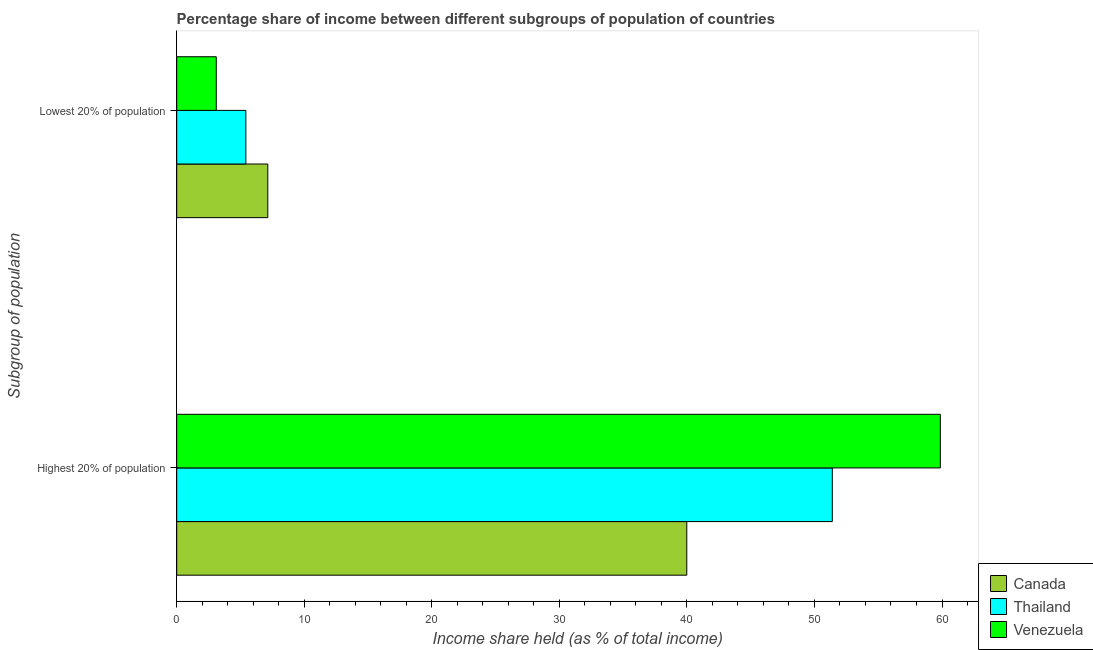How many different coloured bars are there?
Your answer should be very brief. 3. How many groups of bars are there?
Your answer should be very brief. 2. Are the number of bars per tick equal to the number of legend labels?
Your answer should be compact. Yes. How many bars are there on the 2nd tick from the top?
Offer a terse response. 3. How many bars are there on the 1st tick from the bottom?
Give a very brief answer. 3. What is the label of the 2nd group of bars from the top?
Your answer should be very brief. Highest 20% of population. What is the income share held by highest 20% of the population in Canada?
Your answer should be compact. 39.99. Across all countries, what is the maximum income share held by lowest 20% of the population?
Offer a terse response. 7.14. What is the total income share held by highest 20% of the population in the graph?
Your answer should be very brief. 151.26. What is the difference between the income share held by highest 20% of the population in Thailand and that in Canada?
Ensure brevity in your answer.  11.41. What is the difference between the income share held by highest 20% of the population in Canada and the income share held by lowest 20% of the population in Venezuela?
Make the answer very short. 36.89. What is the average income share held by highest 20% of the population per country?
Offer a terse response. 50.42. What is the difference between the income share held by lowest 20% of the population and income share held by highest 20% of the population in Thailand?
Provide a succinct answer. -45.98. What is the ratio of the income share held by lowest 20% of the population in Thailand to that in Venezuela?
Make the answer very short. 1.75. Is the income share held by lowest 20% of the population in Canada less than that in Venezuela?
Your response must be concise. No. What does the 2nd bar from the top in Highest 20% of population represents?
Give a very brief answer. Thailand. What does the 2nd bar from the bottom in Highest 20% of population represents?
Your answer should be compact. Thailand. How many bars are there?
Offer a terse response. 6. Are all the bars in the graph horizontal?
Your response must be concise. Yes. How many countries are there in the graph?
Ensure brevity in your answer.  3. Where does the legend appear in the graph?
Make the answer very short. Bottom right. How many legend labels are there?
Your answer should be very brief. 3. What is the title of the graph?
Your answer should be compact. Percentage share of income between different subgroups of population of countries. Does "Kuwait" appear as one of the legend labels in the graph?
Provide a succinct answer. No. What is the label or title of the X-axis?
Offer a terse response. Income share held (as % of total income). What is the label or title of the Y-axis?
Offer a very short reply. Subgroup of population. What is the Income share held (as % of total income) of Canada in Highest 20% of population?
Ensure brevity in your answer.  39.99. What is the Income share held (as % of total income) in Thailand in Highest 20% of population?
Your answer should be very brief. 51.4. What is the Income share held (as % of total income) in Venezuela in Highest 20% of population?
Your answer should be very brief. 59.87. What is the Income share held (as % of total income) in Canada in Lowest 20% of population?
Ensure brevity in your answer.  7.14. What is the Income share held (as % of total income) in Thailand in Lowest 20% of population?
Your answer should be very brief. 5.42. Across all Subgroup of population, what is the maximum Income share held (as % of total income) of Canada?
Provide a succinct answer. 39.99. Across all Subgroup of population, what is the maximum Income share held (as % of total income) of Thailand?
Make the answer very short. 51.4. Across all Subgroup of population, what is the maximum Income share held (as % of total income) in Venezuela?
Provide a succinct answer. 59.87. Across all Subgroup of population, what is the minimum Income share held (as % of total income) in Canada?
Your answer should be compact. 7.14. Across all Subgroup of population, what is the minimum Income share held (as % of total income) in Thailand?
Provide a short and direct response. 5.42. Across all Subgroup of population, what is the minimum Income share held (as % of total income) of Venezuela?
Your answer should be very brief. 3.1. What is the total Income share held (as % of total income) in Canada in the graph?
Provide a short and direct response. 47.13. What is the total Income share held (as % of total income) of Thailand in the graph?
Keep it short and to the point. 56.82. What is the total Income share held (as % of total income) of Venezuela in the graph?
Keep it short and to the point. 62.97. What is the difference between the Income share held (as % of total income) in Canada in Highest 20% of population and that in Lowest 20% of population?
Your answer should be very brief. 32.85. What is the difference between the Income share held (as % of total income) of Thailand in Highest 20% of population and that in Lowest 20% of population?
Your answer should be compact. 45.98. What is the difference between the Income share held (as % of total income) in Venezuela in Highest 20% of population and that in Lowest 20% of population?
Ensure brevity in your answer.  56.77. What is the difference between the Income share held (as % of total income) in Canada in Highest 20% of population and the Income share held (as % of total income) in Thailand in Lowest 20% of population?
Give a very brief answer. 34.57. What is the difference between the Income share held (as % of total income) of Canada in Highest 20% of population and the Income share held (as % of total income) of Venezuela in Lowest 20% of population?
Give a very brief answer. 36.89. What is the difference between the Income share held (as % of total income) in Thailand in Highest 20% of population and the Income share held (as % of total income) in Venezuela in Lowest 20% of population?
Provide a short and direct response. 48.3. What is the average Income share held (as % of total income) in Canada per Subgroup of population?
Give a very brief answer. 23.57. What is the average Income share held (as % of total income) of Thailand per Subgroup of population?
Your response must be concise. 28.41. What is the average Income share held (as % of total income) in Venezuela per Subgroup of population?
Offer a very short reply. 31.48. What is the difference between the Income share held (as % of total income) of Canada and Income share held (as % of total income) of Thailand in Highest 20% of population?
Your answer should be compact. -11.41. What is the difference between the Income share held (as % of total income) in Canada and Income share held (as % of total income) in Venezuela in Highest 20% of population?
Your answer should be compact. -19.88. What is the difference between the Income share held (as % of total income) in Thailand and Income share held (as % of total income) in Venezuela in Highest 20% of population?
Keep it short and to the point. -8.47. What is the difference between the Income share held (as % of total income) of Canada and Income share held (as % of total income) of Thailand in Lowest 20% of population?
Provide a short and direct response. 1.72. What is the difference between the Income share held (as % of total income) in Canada and Income share held (as % of total income) in Venezuela in Lowest 20% of population?
Offer a very short reply. 4.04. What is the difference between the Income share held (as % of total income) in Thailand and Income share held (as % of total income) in Venezuela in Lowest 20% of population?
Your answer should be very brief. 2.32. What is the ratio of the Income share held (as % of total income) in Canada in Highest 20% of population to that in Lowest 20% of population?
Provide a succinct answer. 5.6. What is the ratio of the Income share held (as % of total income) of Thailand in Highest 20% of population to that in Lowest 20% of population?
Give a very brief answer. 9.48. What is the ratio of the Income share held (as % of total income) of Venezuela in Highest 20% of population to that in Lowest 20% of population?
Your answer should be compact. 19.31. What is the difference between the highest and the second highest Income share held (as % of total income) in Canada?
Your answer should be very brief. 32.85. What is the difference between the highest and the second highest Income share held (as % of total income) in Thailand?
Offer a very short reply. 45.98. What is the difference between the highest and the second highest Income share held (as % of total income) in Venezuela?
Your response must be concise. 56.77. What is the difference between the highest and the lowest Income share held (as % of total income) in Canada?
Offer a very short reply. 32.85. What is the difference between the highest and the lowest Income share held (as % of total income) in Thailand?
Your answer should be very brief. 45.98. What is the difference between the highest and the lowest Income share held (as % of total income) of Venezuela?
Make the answer very short. 56.77. 